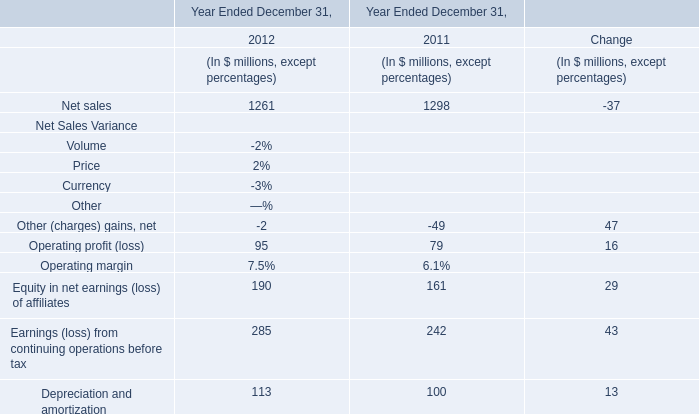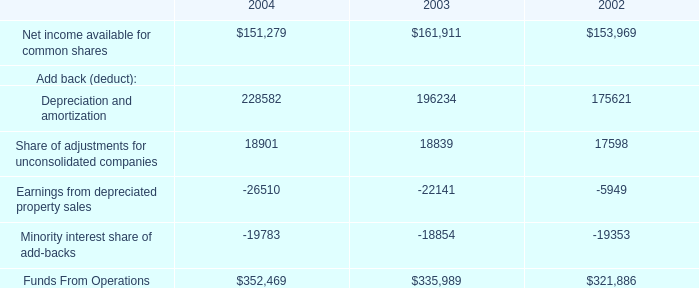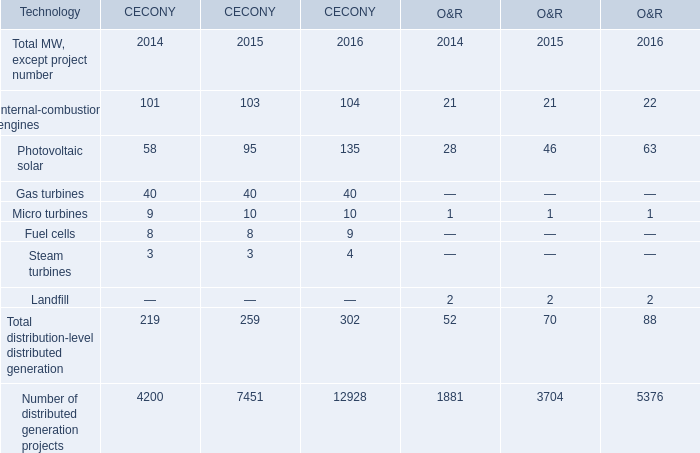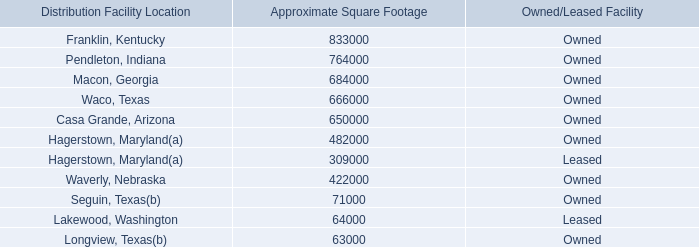what is the total square footage of properties charged to sg&a and not cost of sales? 
Computations: ((8000 + 260000) + 32000)
Answer: 300000.0. 